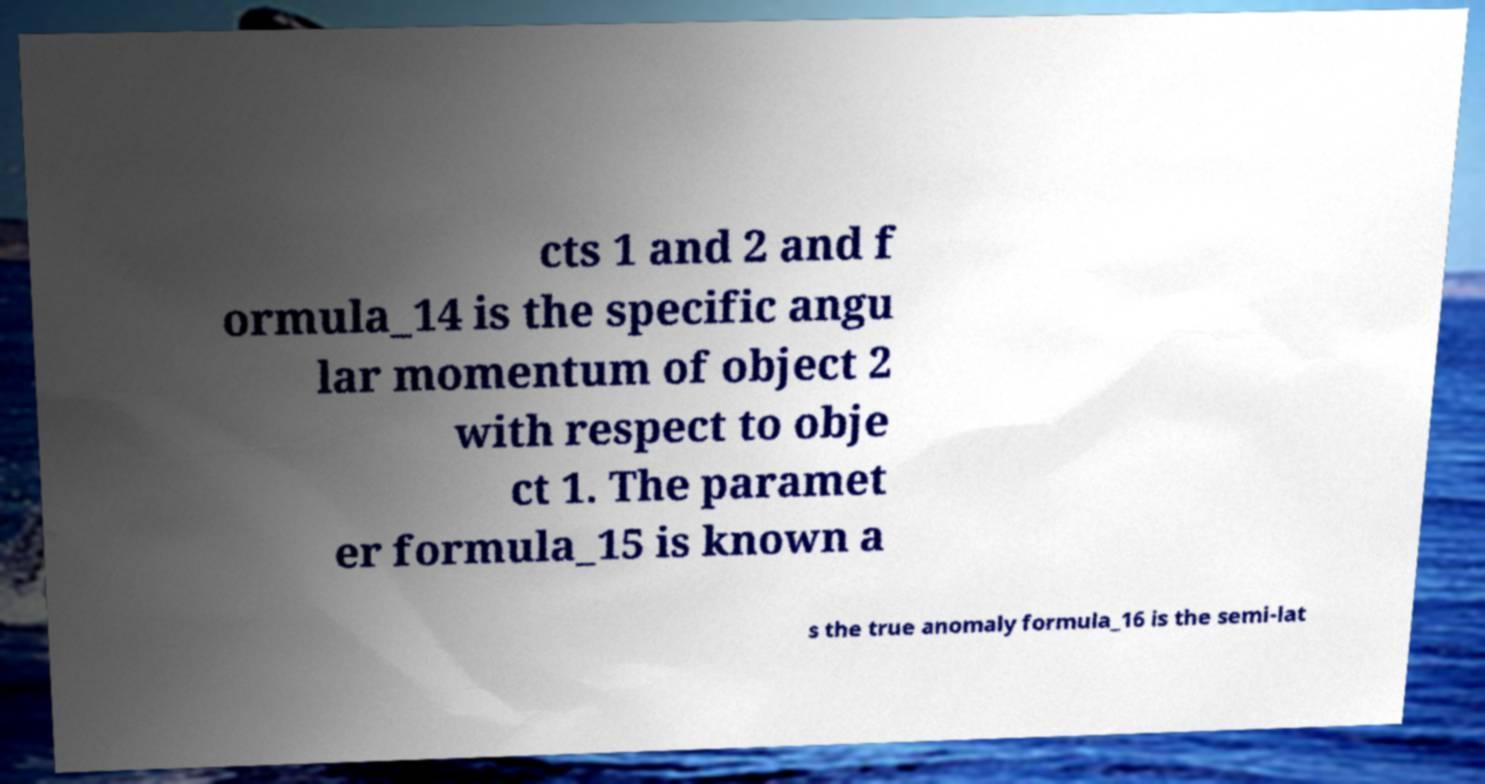Can you read and provide the text displayed in the image?This photo seems to have some interesting text. Can you extract and type it out for me? cts 1 and 2 and f ormula_14 is the specific angu lar momentum of object 2 with respect to obje ct 1. The paramet er formula_15 is known a s the true anomaly formula_16 is the semi-lat 